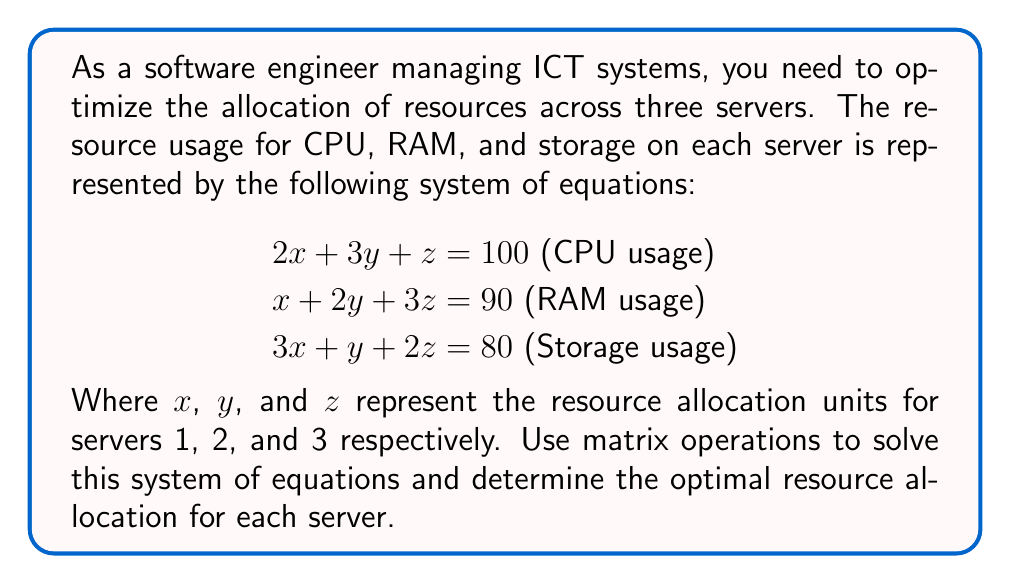Solve this math problem. To solve this system of linear equations using matrix operations, we'll follow these steps:

1) First, let's express the system in matrix form:

   $$\begin{bmatrix}
   2 & 3 & 1 \\
   1 & 2 & 3 \\
   3 & 1 & 2
   \end{bmatrix}
   \begin{bmatrix}
   x \\
   y \\
   z
   \end{bmatrix} =
   \begin{bmatrix}
   100 \\
   90 \\
   80
   \end{bmatrix}$$

2) Let's call the coefficient matrix A, the variable matrix X, and the constant matrix B. So, AX = B.

3) To solve for X, we need to multiply both sides by the inverse of A: $A^{-1}AX = A^{-1}B$

4) Let's calculate $A^{-1}$ using the adjugate method:

   $$A^{-1} = \frac{1}{\det(A)} \text{adj}(A)$$

   Where $\det(A) = 2(2\cdot2 - 3\cdot1) - 3(1\cdot2 - 3\cdot3) + 1(1\cdot1 - 3\cdot2) = -10$

   And $\text{adj}(A) = \begin{bmatrix}
   1 & -7 & 5 \\
   5 & -4 & -3 \\
   -7 & 11 & -1
   \end{bmatrix}$

   So, $A^{-1} = -\frac{1}{10}\begin{bmatrix}
   1 & -7 & 5 \\
   5 & -4 & -3 \\
   -7 & 11 & -1
   \end{bmatrix}$

5) Now we can solve for X:

   $$X = A^{-1}B = -\frac{1}{10}\begin{bmatrix}
   1 & -7 & 5 \\
   5 & -4 & -3 \\
   -7 & 11 & -1
   \end{bmatrix}
   \begin{bmatrix}
   100 \\
   90 \\
   80
   \end{bmatrix}$$

6) Multiplying these matrices:

   $$X = -\frac{1}{10}\begin{bmatrix}
   100 - 630 + 400 \\
   500 - 360 - 240 \\
   -700 + 990 - 80
   \end{bmatrix} = \begin{bmatrix}
   13 \\
   -10 \\
   21
   \end{bmatrix}$$

Therefore, $x = 13$, $y = -10$, and $z = 21$.
Answer: The optimal resource allocation is 13 units for server 1, -10 units for server 2, and 21 units for server 3. However, since negative resource allocation is not practical, this solution suggests that the current system constraints are not feasible and the resource allocation strategy needs to be reconsidered. 